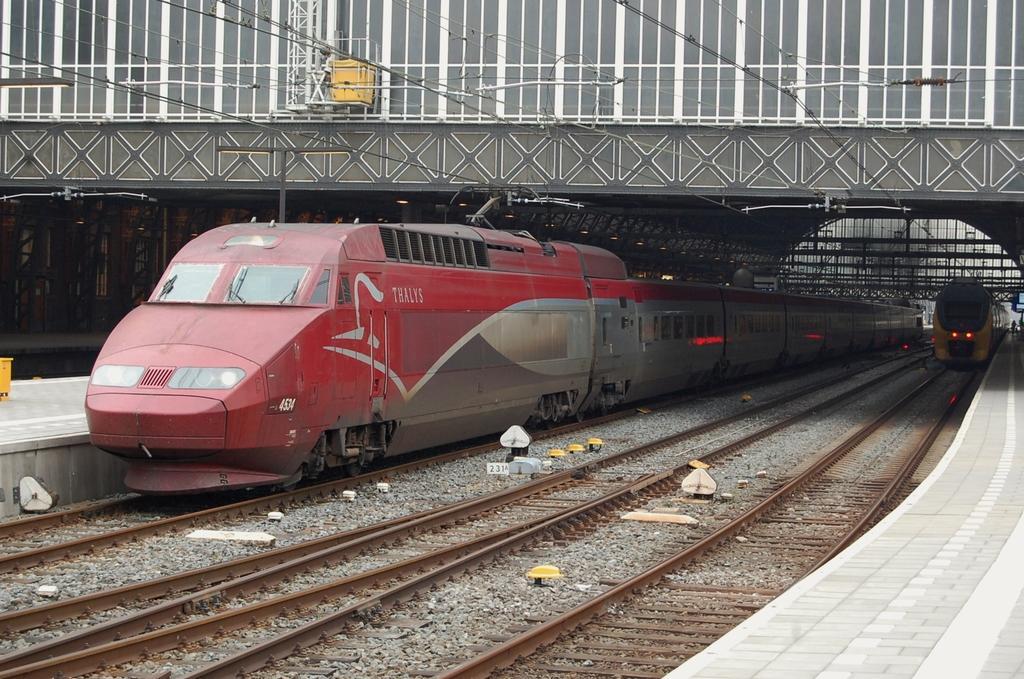In one or two sentences, can you explain what this image depicts? In this image in the center there are two trains, at the bottom there is a railway track and pavement. At the top of the image there is a bridge and some wires, and in the background there are some poles and some objects. 